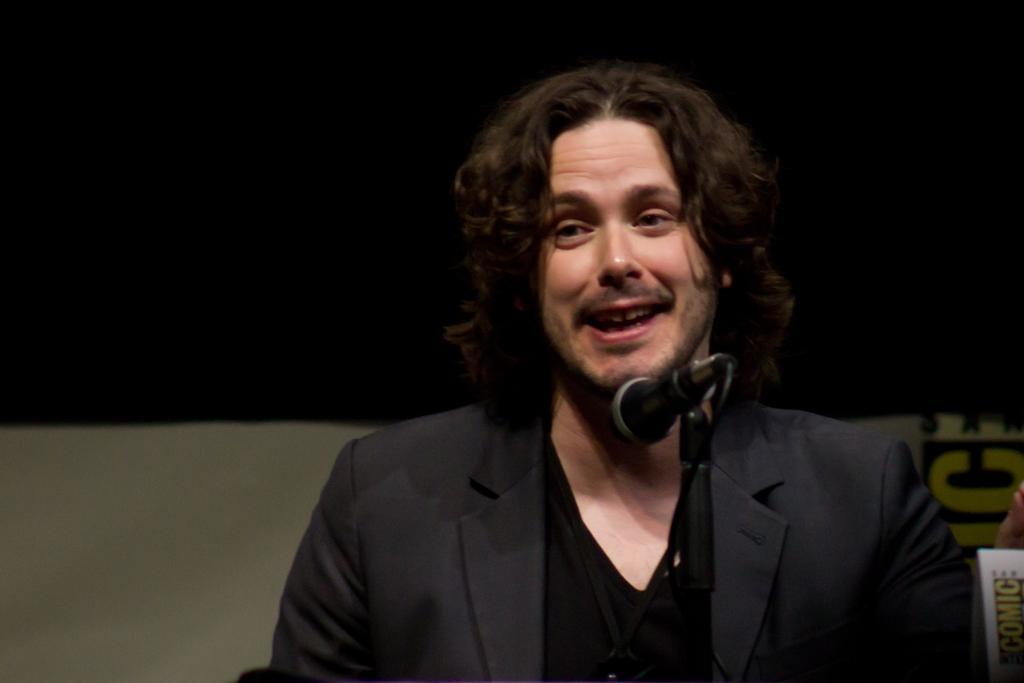Can you describe this image briefly? In this image we can see a man in black suit in front of the mike. 